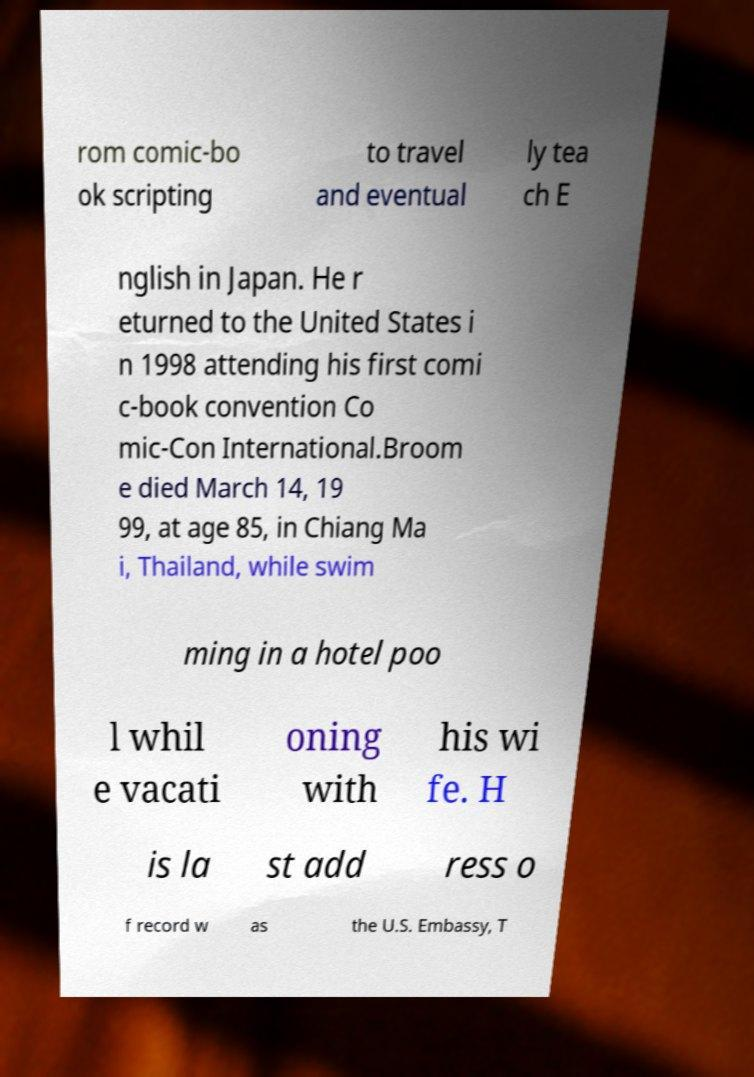What messages or text are displayed in this image? I need them in a readable, typed format. rom comic-bo ok scripting to travel and eventual ly tea ch E nglish in Japan. He r eturned to the United States i n 1998 attending his first comi c-book convention Co mic-Con International.Broom e died March 14, 19 99, at age 85, in Chiang Ma i, Thailand, while swim ming in a hotel poo l whil e vacati oning with his wi fe. H is la st add ress o f record w as the U.S. Embassy, T 